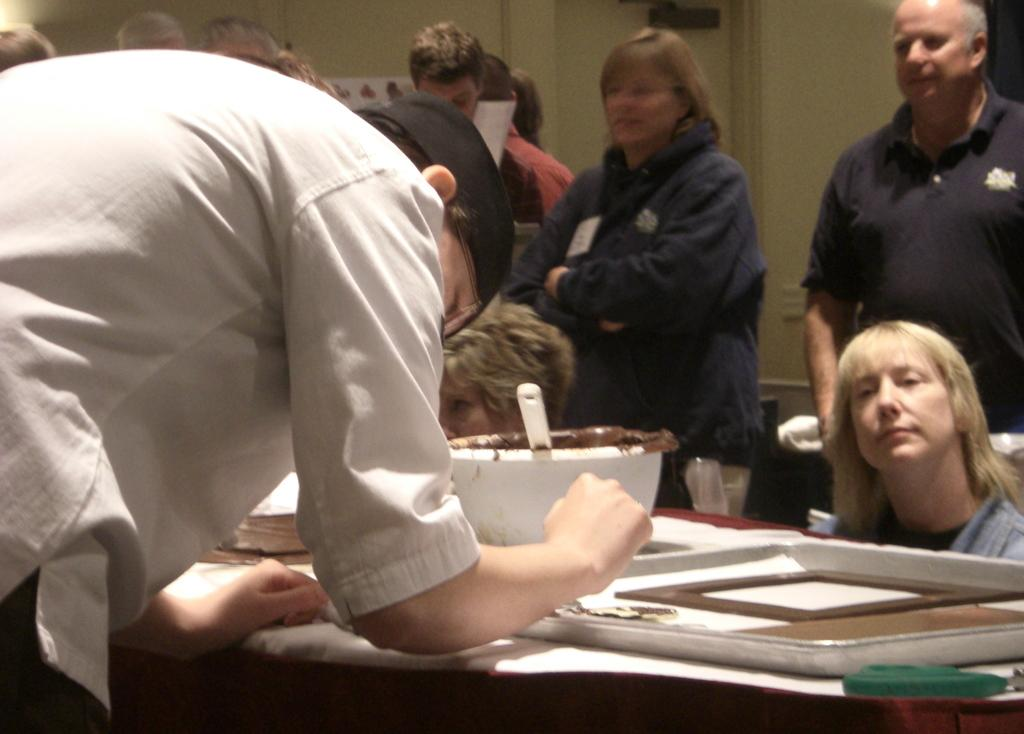How many people are in the image? There is a group of people in the image, but the exact number cannot be determined from the provided facts. What object can be used for eating or serving in the image? There is a spoon and a bowl visible in the image. What is on the table in the image? There is a tray on a table in the image. What can be seen in the background of the image? There is a wall in the background of the image. What type of silver is used to make the air in the image? There is no silver or air present in the image. How much sugar is visible in the image? There is no sugar visible in the image. 